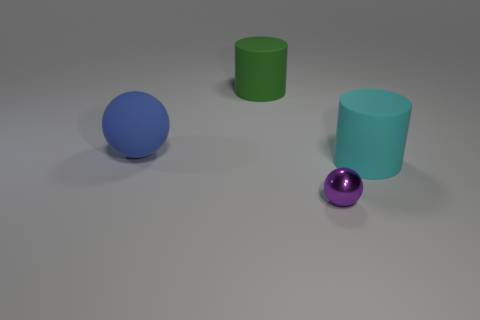Add 1 large blue cylinders. How many objects exist? 5 Subtract all cyan cylinders. How many cylinders are left? 1 Subtract all brown cylinders. Subtract all blue cubes. How many cylinders are left? 2 Subtract all yellow balls. How many green cylinders are left? 1 Subtract all big brown balls. Subtract all big cylinders. How many objects are left? 2 Add 4 big cylinders. How many big cylinders are left? 6 Add 1 big green shiny objects. How many big green shiny objects exist? 1 Subtract 1 green cylinders. How many objects are left? 3 Subtract 1 spheres. How many spheres are left? 1 